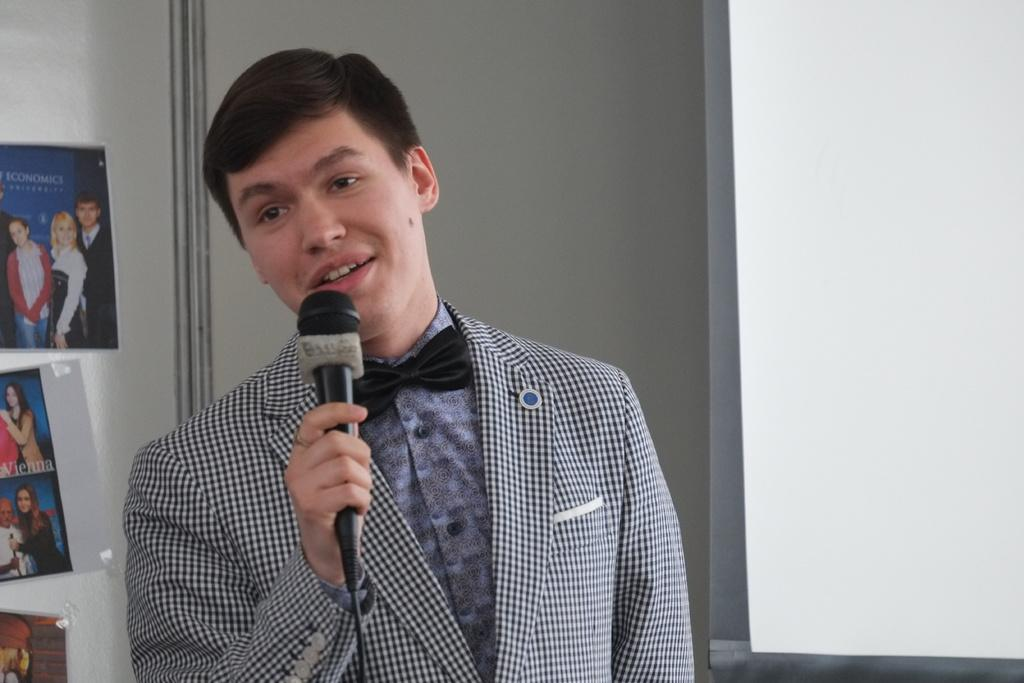Who is the main subject in the image? There is a man in the image. What is the man doing in the image? The man is talking. How is the man communicating in the image? The man is using a microphone. What else can be seen in the image besides the man? There are photo frames visible in the image. What type of marble is being used to decorate the floor in the image? There is no marble visible in the image; it only features a man talking with a microphone and photo frames. Is there a fight happening in the image? No, there is no fight depicted in the image; the man is simply talking with a microphone. 